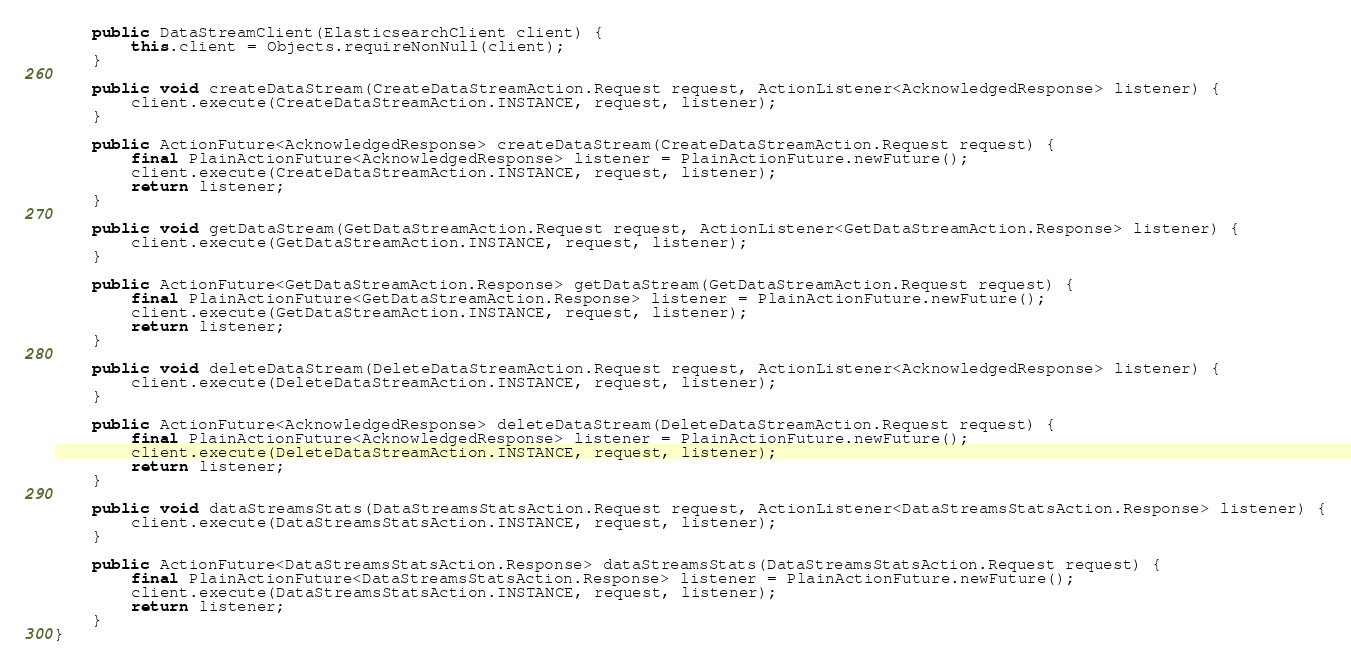<code> <loc_0><loc_0><loc_500><loc_500><_Java_>
    public DataStreamClient(ElasticsearchClient client) {
        this.client = Objects.requireNonNull(client);
    }

    public void createDataStream(CreateDataStreamAction.Request request, ActionListener<AcknowledgedResponse> listener) {
        client.execute(CreateDataStreamAction.INSTANCE, request, listener);
    }

    public ActionFuture<AcknowledgedResponse> createDataStream(CreateDataStreamAction.Request request) {
        final PlainActionFuture<AcknowledgedResponse> listener = PlainActionFuture.newFuture();
        client.execute(CreateDataStreamAction.INSTANCE, request, listener);
        return listener;
    }

    public void getDataStream(GetDataStreamAction.Request request, ActionListener<GetDataStreamAction.Response> listener) {
        client.execute(GetDataStreamAction.INSTANCE, request, listener);
    }

    public ActionFuture<GetDataStreamAction.Response> getDataStream(GetDataStreamAction.Request request) {
        final PlainActionFuture<GetDataStreamAction.Response> listener = PlainActionFuture.newFuture();
        client.execute(GetDataStreamAction.INSTANCE, request, listener);
        return listener;
    }

    public void deleteDataStream(DeleteDataStreamAction.Request request, ActionListener<AcknowledgedResponse> listener) {
        client.execute(DeleteDataStreamAction.INSTANCE, request, listener);
    }

    public ActionFuture<AcknowledgedResponse> deleteDataStream(DeleteDataStreamAction.Request request) {
        final PlainActionFuture<AcknowledgedResponse> listener = PlainActionFuture.newFuture();
        client.execute(DeleteDataStreamAction.INSTANCE, request, listener);
        return listener;
    }

    public void dataStreamsStats(DataStreamsStatsAction.Request request, ActionListener<DataStreamsStatsAction.Response> listener) {
        client.execute(DataStreamsStatsAction.INSTANCE, request, listener);
    }

    public ActionFuture<DataStreamsStatsAction.Response> dataStreamsStats(DataStreamsStatsAction.Request request) {
        final PlainActionFuture<DataStreamsStatsAction.Response> listener = PlainActionFuture.newFuture();
        client.execute(DataStreamsStatsAction.INSTANCE, request, listener);
        return listener;
    }
}
</code> 